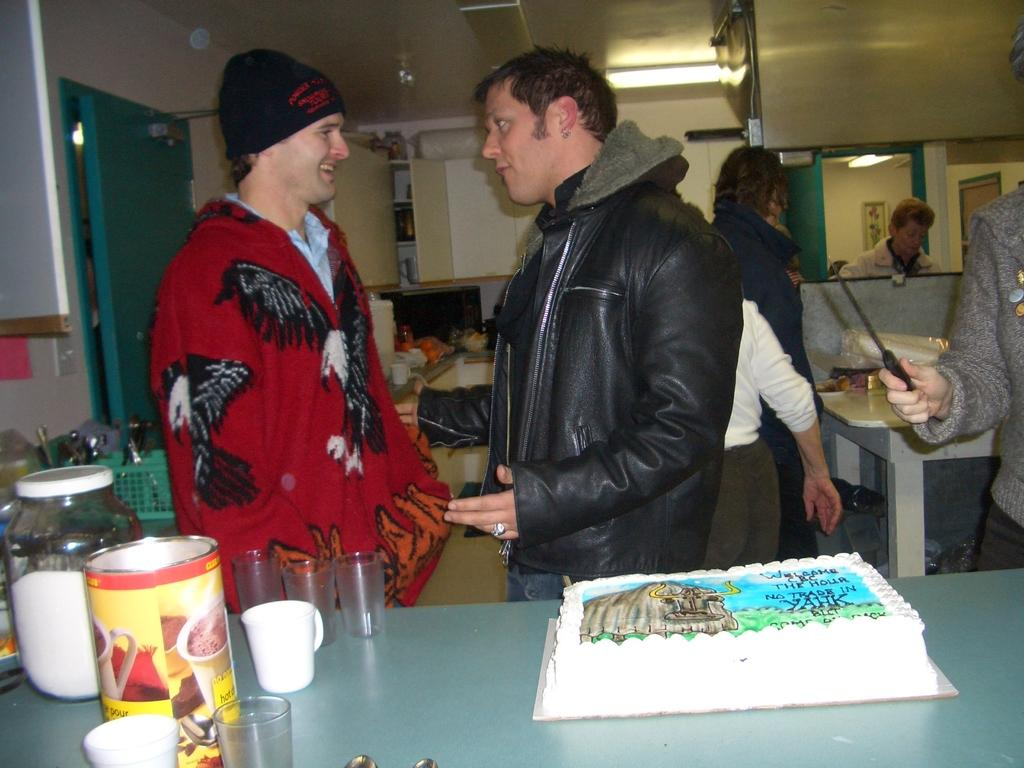What is the main food item in the image? There is a cake in the image. What can be seen beside the cake? There are glasses in the image. What other items are visible in the front of the image? There are other items in the front of the image. Can you describe the people in the image? People are standing in the image. What is present at the top of the image? There are lights at the top of the image. What architectural features can be seen in the image? There are doors in the image. How many friends are visible on the moon in the image? There is no moon or friends present in the image. 